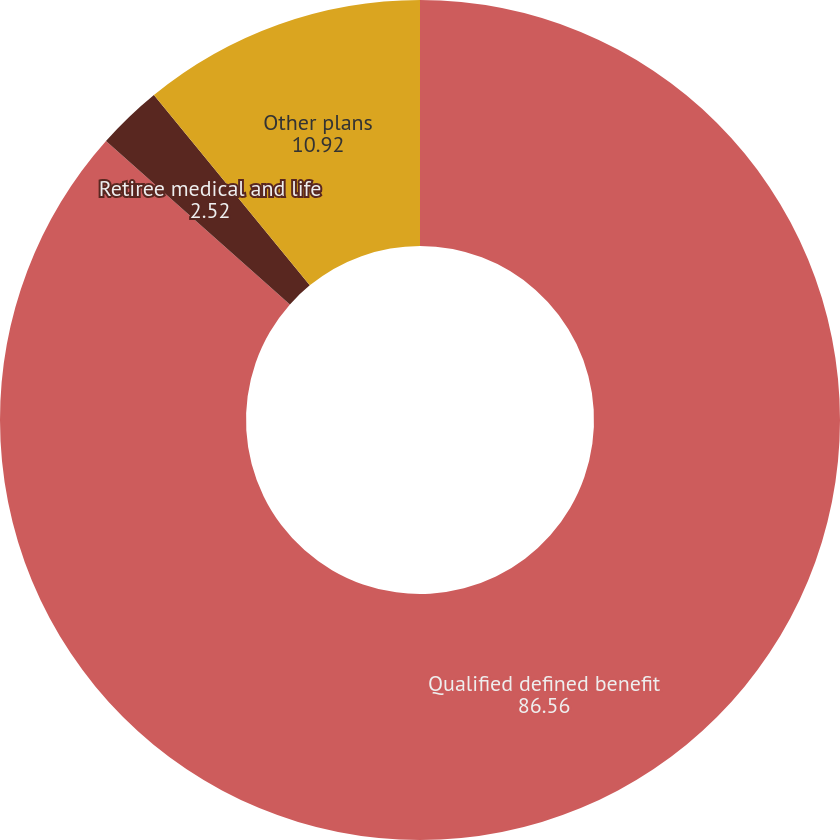Convert chart. <chart><loc_0><loc_0><loc_500><loc_500><pie_chart><fcel>Qualified defined benefit<fcel>Retiree medical and life<fcel>Other plans<nl><fcel>86.56%<fcel>2.52%<fcel>10.92%<nl></chart> 